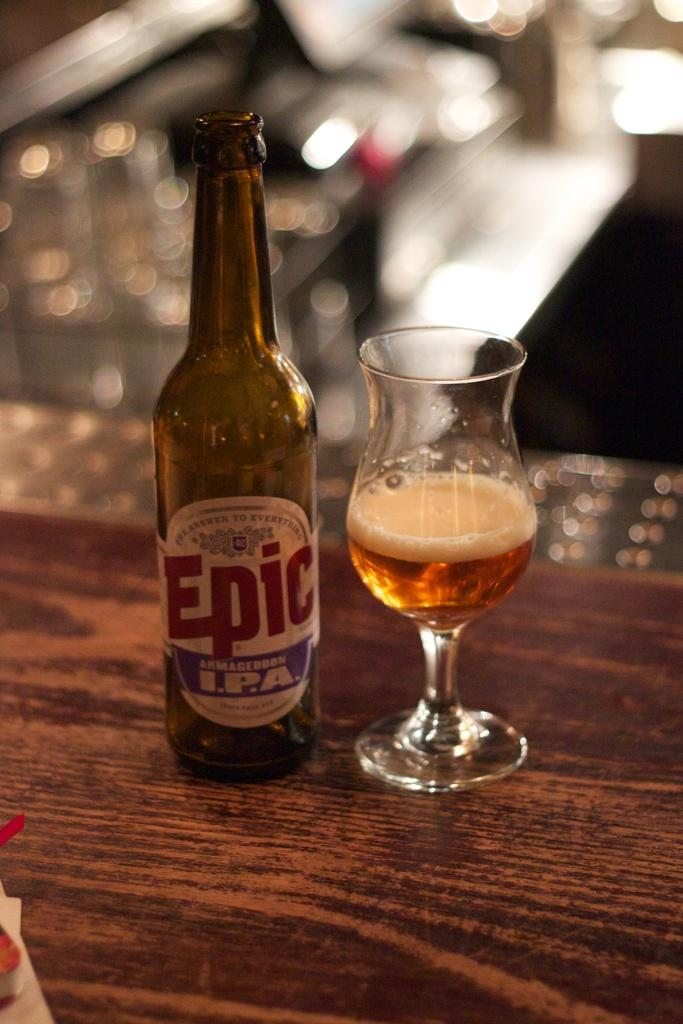<image>
Write a terse but informative summary of the picture. the name Epic is on the front of a bottle 